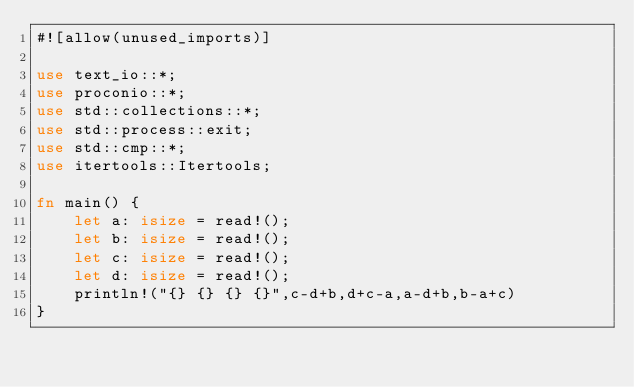Convert code to text. <code><loc_0><loc_0><loc_500><loc_500><_Rust_>#![allow(unused_imports)]

use text_io::*;
use proconio::*;
use std::collections::*;
use std::process::exit;
use std::cmp::*;
use itertools::Itertools;

fn main() {
    let a: isize = read!();
    let b: isize = read!();
    let c: isize = read!();
    let d: isize = read!();
    println!("{} {} {} {}",c-d+b,d+c-a,a-d+b,b-a+c)
}</code> 